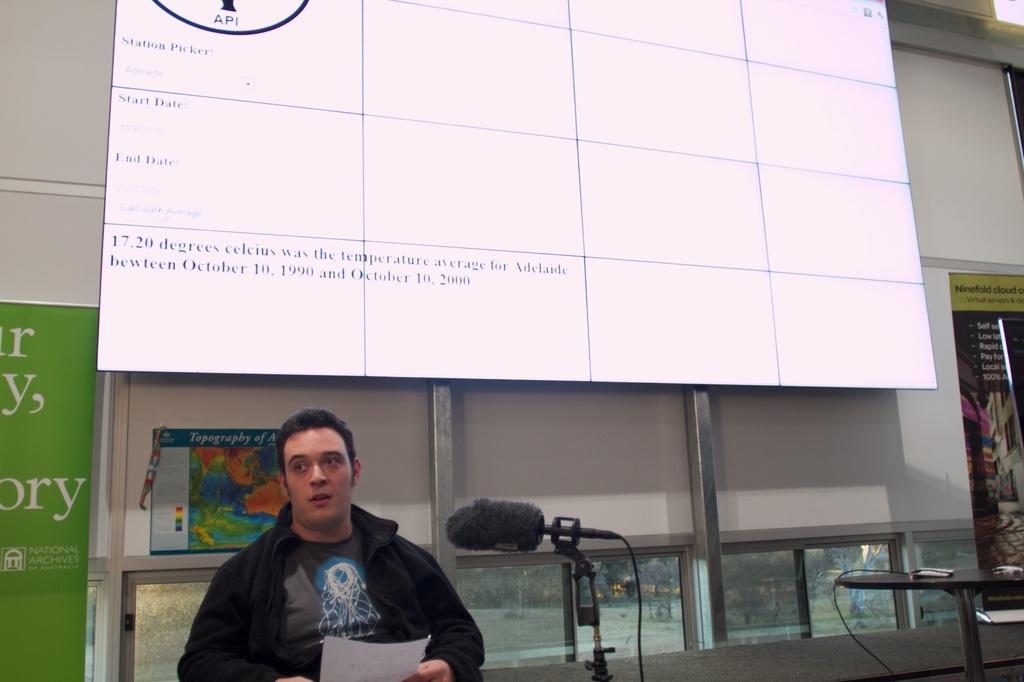In one or two sentences, can you explain what this image depicts? At the bottom of the image we can see a man standing and holding a paper in his hand. In the center there is a mic placed on the stand. On the right we can see a table. In the background there is a screen, boards and a wall. 